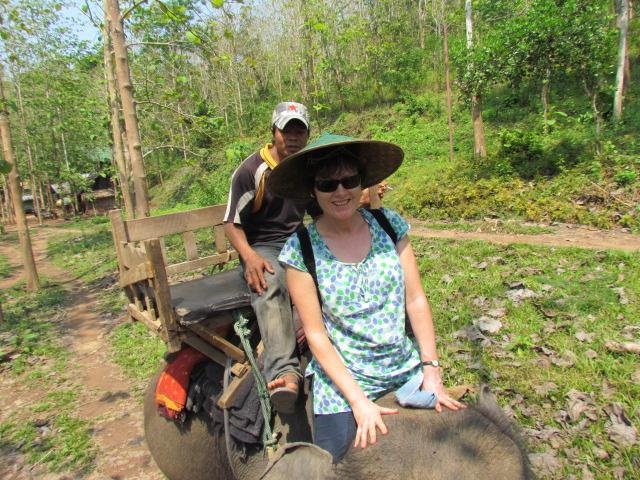Who is guiding the elephant? man 